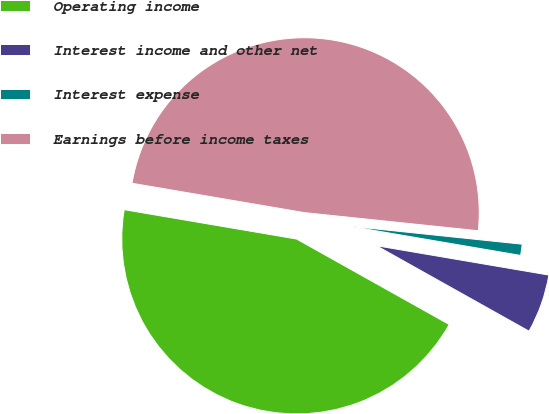<chart> <loc_0><loc_0><loc_500><loc_500><pie_chart><fcel>Operating income<fcel>Interest income and other net<fcel>Interest expense<fcel>Earnings before income taxes<nl><fcel>44.56%<fcel>5.44%<fcel>1.03%<fcel>48.97%<nl></chart> 